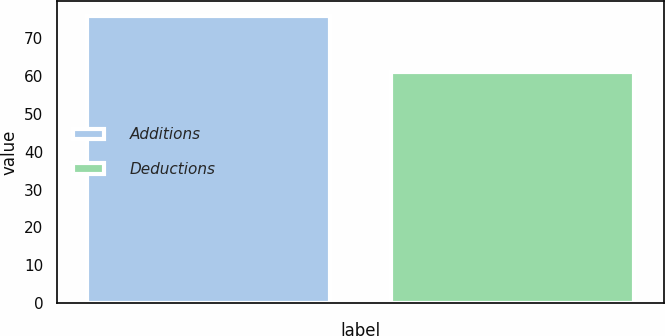<chart> <loc_0><loc_0><loc_500><loc_500><bar_chart><fcel>Additions<fcel>Deductions<nl><fcel>76<fcel>61<nl></chart> 